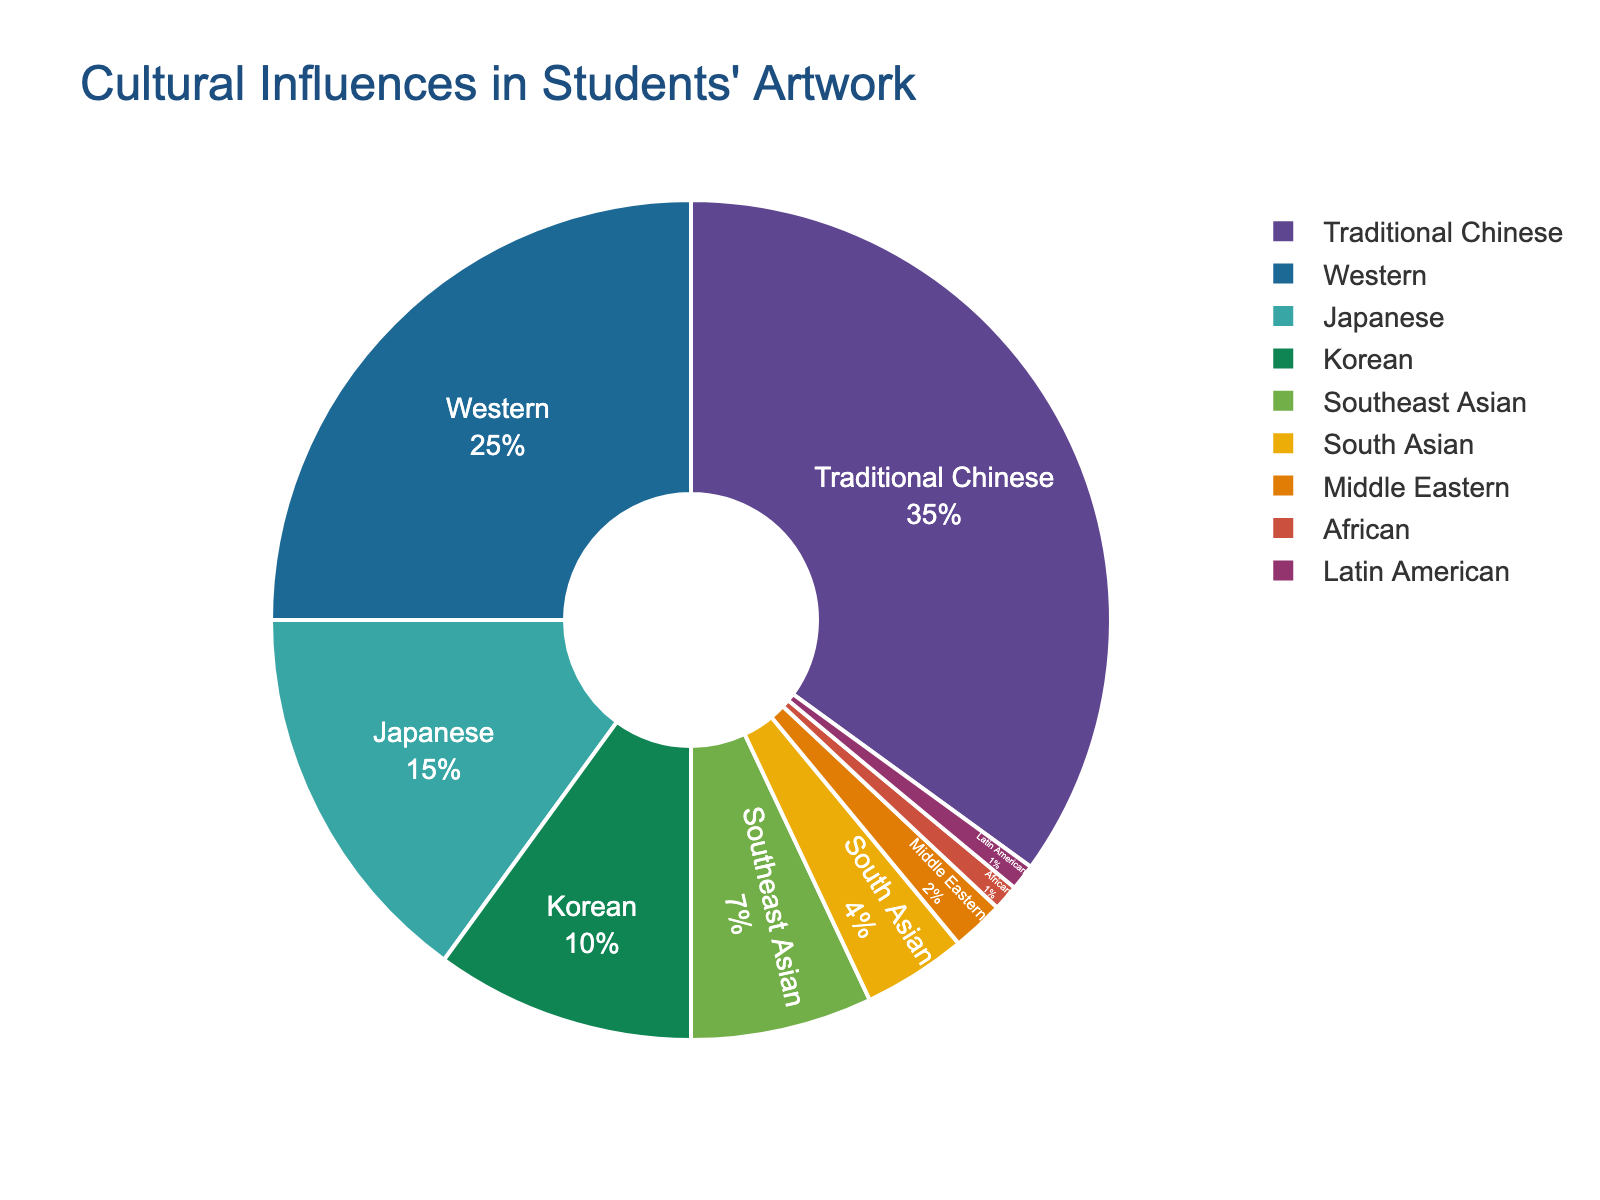What percentage of students' artwork is influenced by Southeast Asian culture? By looking at the pie chart, we can see the segment labeled "Southeast Asian" which shows the percentage clearly.
Answer: 7% Which cultural influence has the highest representation in students' artwork? By identifying the largest segment of the pie chart and reading its label, we determine that "Traditional Chinese" has the highest percentage.
Answer: Traditional Chinese How does the representation of Western cultural influence compare to that of Japanese cultural influence? Comparing the segments labeled "Western" and "Japanese," we see that Western influence is at 25% and Japanese influence is at 15%. Thus, Western influence is higher.
Answer: Western is higher What is the combined percentage of students' artwork influenced by Korean and South Asian cultures? First, identify the percentages for Korean (10%) and South Asian (4%), then add them together: 10% + 4% = 14%.
Answer: 14% Which cultural influences have the smallest and equal representation in students' artwork? By looking at the segments with the smallest percentages, we see that both "African" and "Latin American" are at 1%.
Answer: African and Latin American What is the difference in percentage between Traditional Chinese and Middle Eastern influences in students' artwork? Identify Traditional Chinese (35%) and Middle Eastern (2%) percentages, then subtract the smaller from the larger: 35% - 2% = 33%.
Answer: 33% If we add the percentages of Western, Japanese, and Korean cultural influences, what would be the total? Identify the percentages for Western (25%), Japanese (15%), and Korean (10%), then sum them: 25% + 15% + 10% = 50%.
Answer: 50% What is the percentage difference between Southeast Asian and South Asian cultural influences in students' artwork? Identify Southeast Asian (7%) and South Asian (4%) percentages, then subtract the smaller from the larger: 7% - 4% = 3%.
Answer: 3% Is the percentage of artwork influenced by Traditional Chinese culture more than double the combined percentage of African and Latin American influences? First, find the combined percentage of African (1%) and Latin American (1%): 1% + 1% = 2%. Then, double this value: 2% * 2 = 4%. Finally, compare it to Traditional Chinese (35%). Since 35% > 4%, the answer is yes.
Answer: Yes Which segment occupies the second-largest portion of the pie chart? By visually identifying the largest segment and then determining the next largest, we find that "Western" comes after "Traditional Chinese."
Answer: Western 